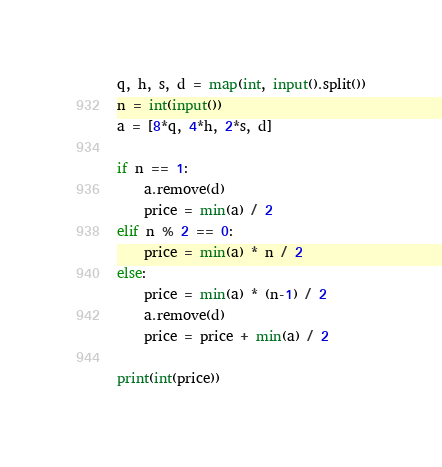<code> <loc_0><loc_0><loc_500><loc_500><_Python_>q, h, s, d = map(int, input().split())
n = int(input())
a = [8*q, 4*h, 2*s, d]

if n == 1:
    a.remove(d)
    price = min(a) / 2
elif n % 2 == 0:
    price = min(a) * n / 2
else:
    price = min(a) * (n-1) / 2
    a.remove(d)
    price = price + min(a) / 2

print(int(price))</code> 